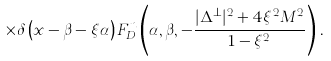<formula> <loc_0><loc_0><loc_500><loc_500>\times \delta \left ( x - \beta - \xi \alpha \right ) F _ { D } ^ { n } \left ( \alpha , \beta , - \frac { | \Delta ^ { \perp } | ^ { 2 } + 4 \xi ^ { 2 } M ^ { 2 } } { 1 - \xi ^ { 2 } } \right ) \, .</formula> 